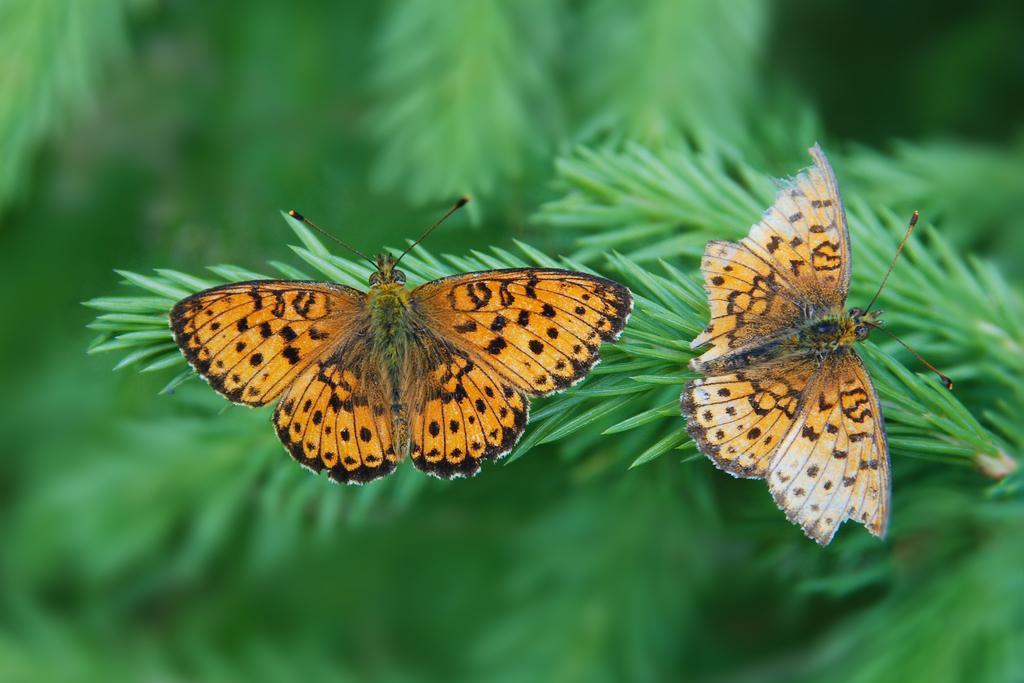Can you describe this image briefly? There are two butterflies, which are on the leaves. The background looks green in color, which is blur. 